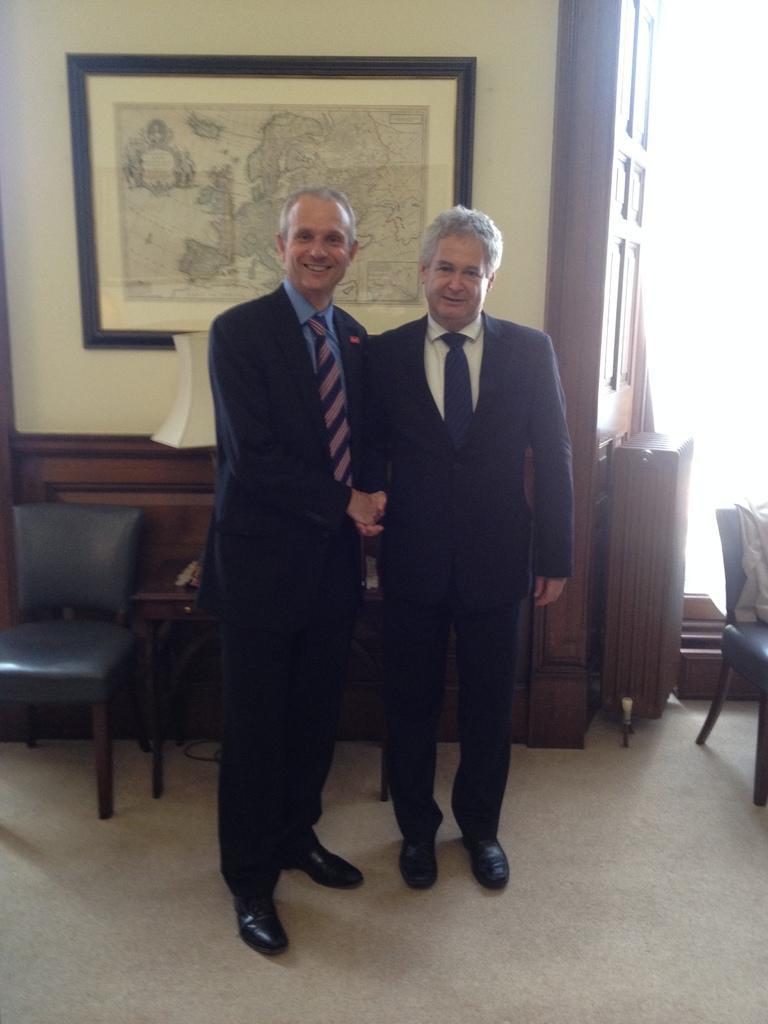Please provide a concise description of this image. In this image I can see two men wearing black suit holding their hands together. I can also see this chair and a wall with a photo. 